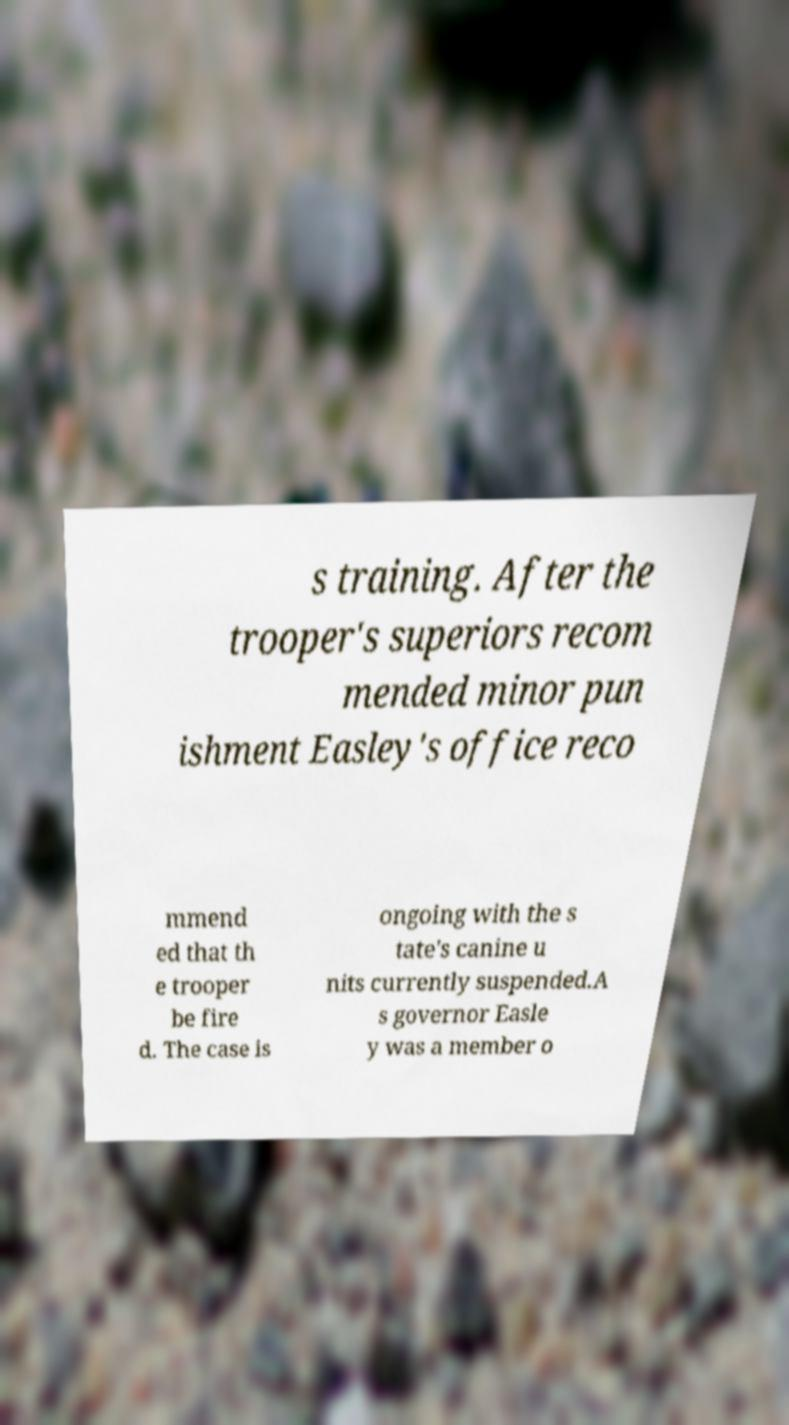Could you extract and type out the text from this image? s training. After the trooper's superiors recom mended minor pun ishment Easley's office reco mmend ed that th e trooper be fire d. The case is ongoing with the s tate's canine u nits currently suspended.A s governor Easle y was a member o 